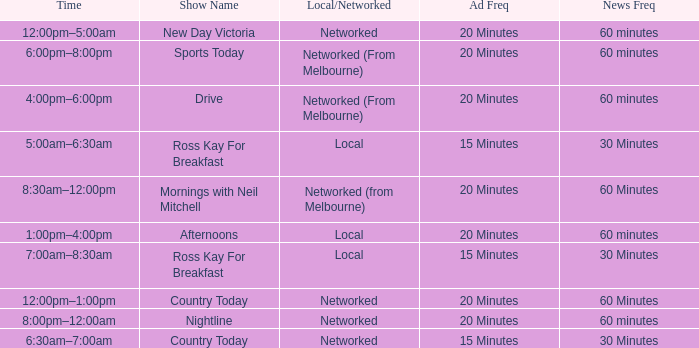What News Freq has a Time of 1:00pm–4:00pm? 60 minutes. 